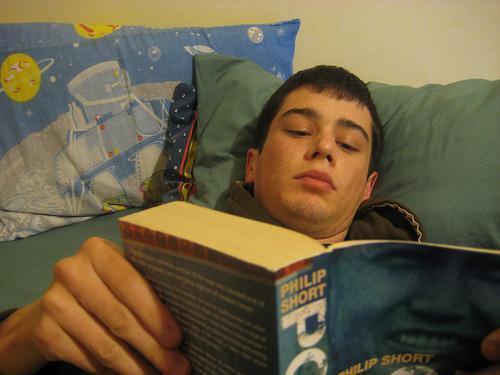How many pillows are in the picture?
Give a very brief answer. 3. 